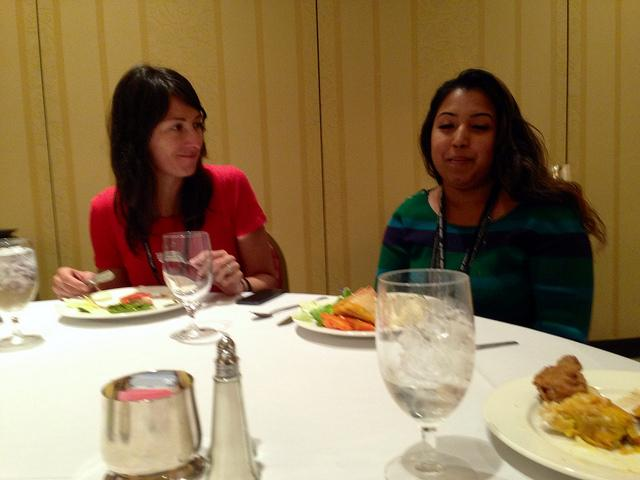What part of the meal is being eaten? entree 